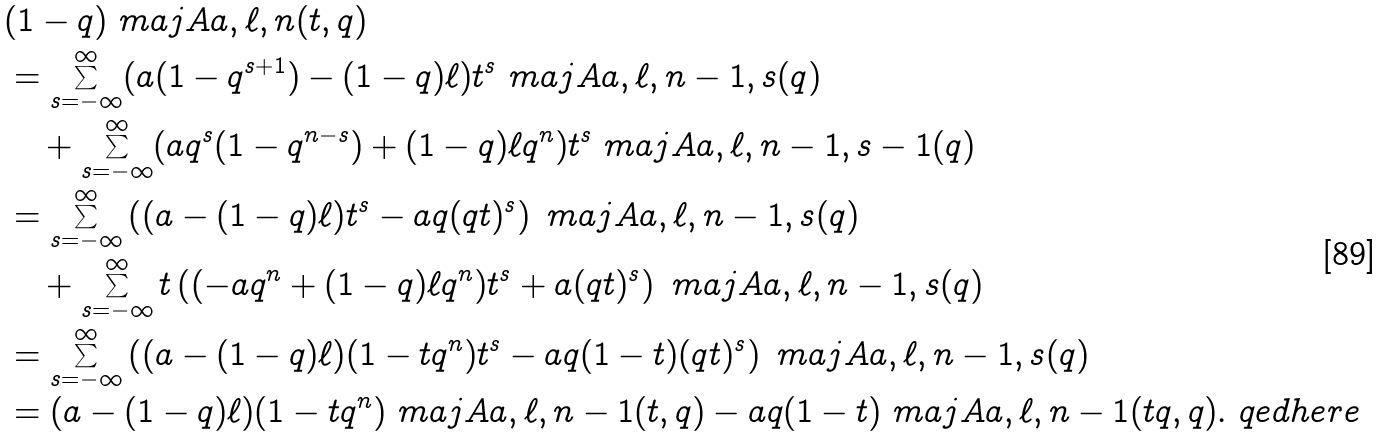Convert formula to latex. <formula><loc_0><loc_0><loc_500><loc_500>& ( 1 - q ) \ m a j A { a , \ell , n } ( t , q ) \\ & = \sum _ { s = - \infty } ^ { \infty } ( a ( 1 - q ^ { s + 1 } ) - ( 1 - q ) \ell ) t ^ { s } \ m a j A { a , \ell , n - 1 , s } ( q ) \\ & \quad + \sum _ { s = - \infty } ^ { \infty } ( a q ^ { s } ( 1 - q ^ { n - s } ) + ( 1 - q ) \ell q ^ { n } ) t ^ { s } \ m a j A { a , \ell , n - 1 , s - 1 } ( q ) \\ & = \sum _ { s = - \infty } ^ { \infty } \left ( ( a - ( 1 - q ) \ell ) t ^ { s } - a q ( q t ) ^ { s } \right ) \ m a j A { a , \ell , n - 1 , s } ( q ) \\ & \quad + \sum _ { s = - \infty } ^ { \infty } t \left ( ( - a q ^ { n } + ( 1 - q ) \ell q ^ { n } ) t ^ { s } + a ( q t ) ^ { s } \right ) \ m a j A { a , \ell , n - 1 , s } ( q ) \\ & = \sum _ { s = - \infty } ^ { \infty } \left ( ( a - ( 1 - q ) \ell ) ( 1 - t q ^ { n } ) t ^ { s } - a q ( 1 - t ) ( q t ) ^ { s } \right ) \ m a j A { a , \ell , n - 1 , s } ( q ) \\ & = ( a - ( 1 - q ) \ell ) ( 1 - t q ^ { n } ) \ m a j A { a , \ell , n - 1 } ( t , q ) - a q ( 1 - t ) \ m a j A { a , \ell , n - 1 } ( t q , q ) . \ q e d h e r e</formula> 